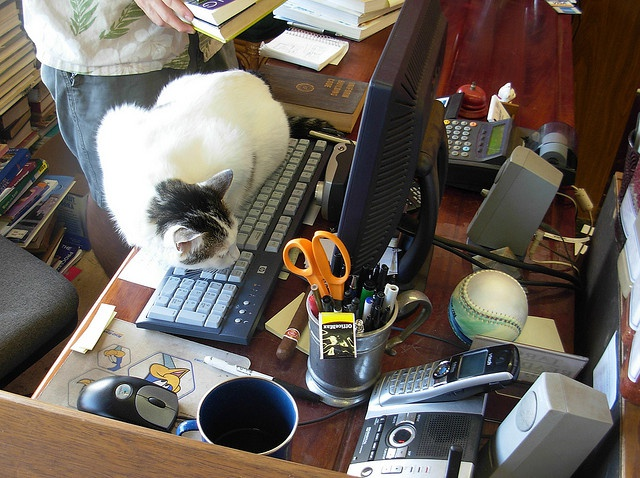Describe the objects in this image and their specific colors. I can see cat in gray, white, beige, and darkgray tones, tv in gray, black, maroon, and navy tones, people in gray, lightgray, and darkgray tones, keyboard in gray, black, lightblue, and darkblue tones, and chair in gray and black tones in this image. 